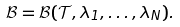<formula> <loc_0><loc_0><loc_500><loc_500>\mathcal { B } = \mathcal { B } ( \mathcal { T } , \lambda _ { 1 } , \dots , \lambda _ { N } ) .</formula> 